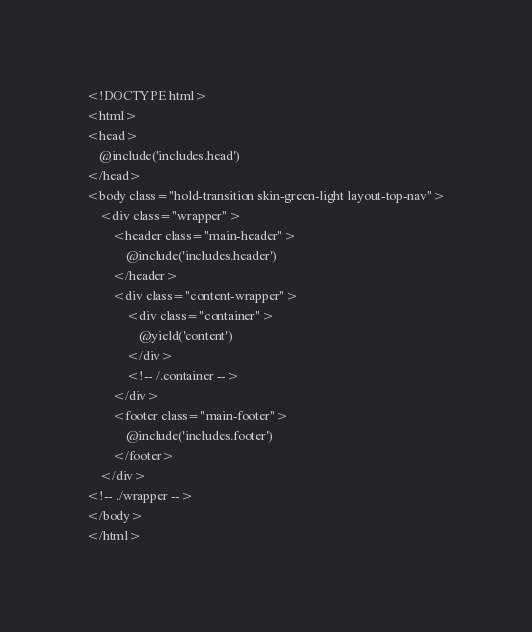<code> <loc_0><loc_0><loc_500><loc_500><_PHP_><!DOCTYPE html>
<html>
<head>
	@include('includes.head')
</head>
<body class="hold-transition skin-green-light layout-top-nav">
	<div class="wrapper">
		<header class="main-header">
			@include('includes.header')
		</header>
		<div class="content-wrapper">
			<div class="container">
				@yield('content')
			</div>
			<!-- /.container -->
		</div>
		<footer class="main-footer">
			@include('includes.footer')
		</footer>
	</div>
<!-- ./wrapper -->
</body>
</html></code> 